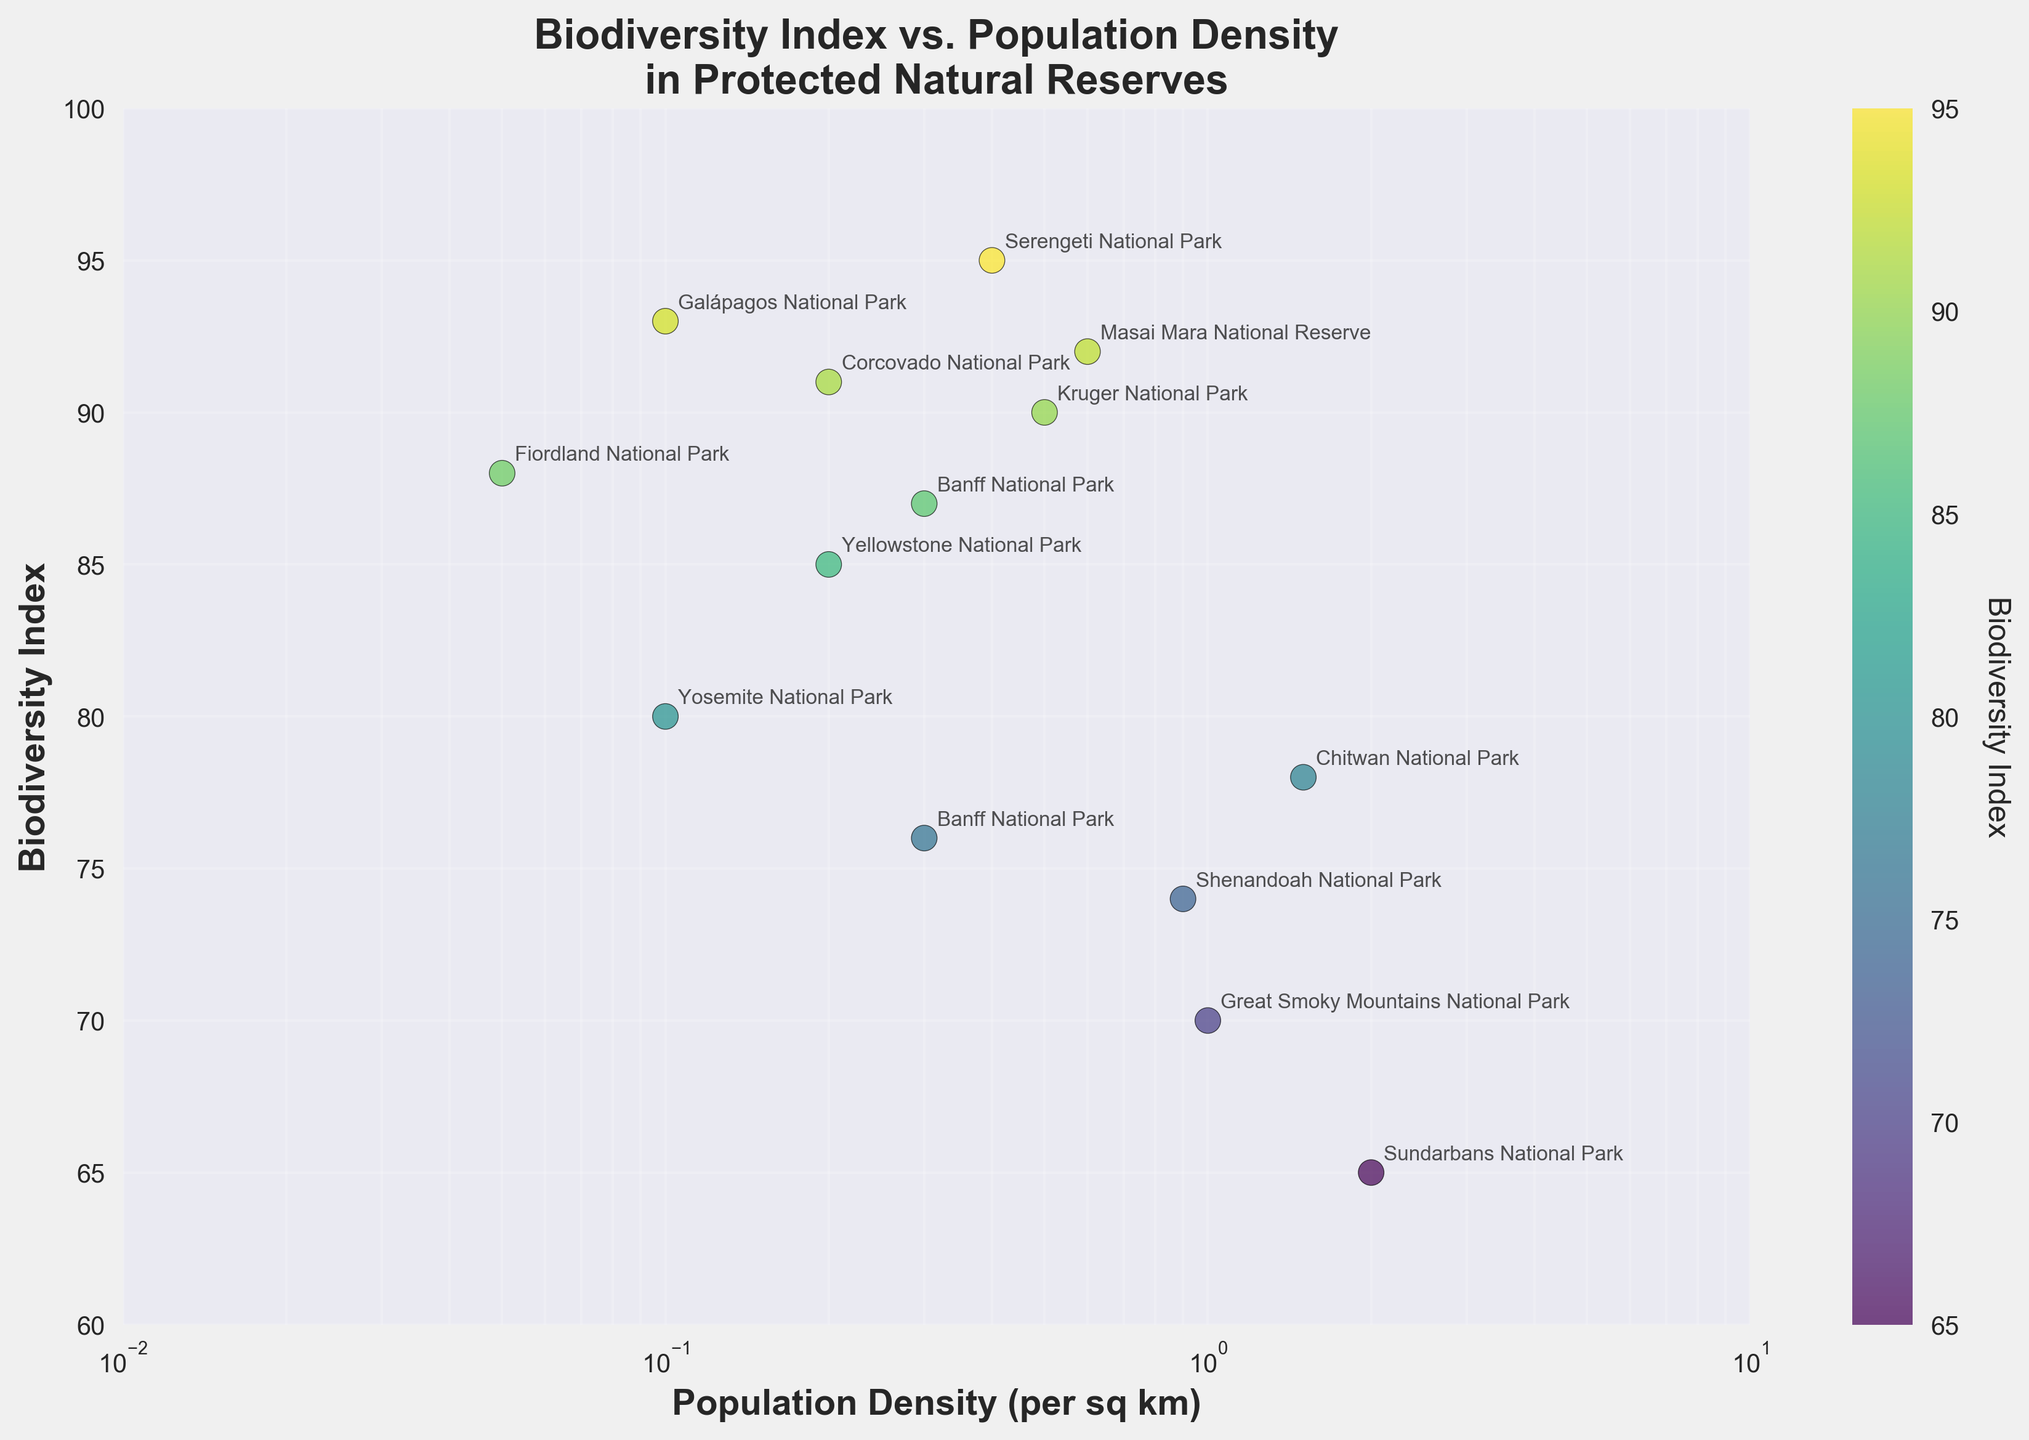What is the title of the scatter plot? The title is usually the text at the top of the figure describing the content. Here it states "Biodiversity Index vs. Population Density in Protected Natural Reserves".
Answer: Biodiversity Index vs. Population Density in Protected Natural Reserves Which natural reserve has the highest Biodiversity Index and what is its value? Look for the point with the maximum Biodiversity Index value on the y-axis. The highest point corresponds to Serengeti National Park with a Biodiversity Index of 95.
Answer: Serengeti National Park, 95 What is the range of the x-axis (Population Density)? Check the label of the x-axis and the scaling. The axis uses a logarithmic scale ranging from 0.01 to 10.
Answer: 0.01 to 10 How does Fiordland National Park's Population Density compare to Galápagos National Park's? Locate both points on the scatter plot and compare their positions on the logarithmic x-axis. Fiordland is at 0.05 while the Galápagos is at 0.1.
Answer: Fiordland < Galápagos Which reserve has a Population Density of 1.0 per sq km and what is its Biodiversity Index? Find the point at (1.0, y) on the plot. The corresponding Biodiversity Index for Great Smoky Mountains National Park is 70.
Answer: Great Smoky Mountains National Park, 70 Are there any reserves with the same Population Density and different Biodiversity Index? Look for points vertically aligned on the plot. Banff National Park appears twice with a Population Density of 0.3 but different Biodiversity Indices (76 and 87).
Answer: Yes, Banff National Park What is the average Biodiversity Index of the reserves with a Population Density of less than 0.5 per sq km? Identify reserves with Population Density < 0.5: Yellowstone (85), Kruger (90), Banff (87 and 76), Yosemite (80), Serengeti (95), Fiordland (88), Galápagos (93), and Corcovado (91). Sum of Biodiversity Indices is 785. Average = 785 / 9 = 87.22.
Answer: 87.22 Do any reserves have a Population Density greater than or equal to 1.5 per sq km and if so, what are their Biodiversity Indices? Find points with Population Density >= 1.5 on the plot. Sundarbans and Chitwan reserves fall in this category with Biodiversity Indices of 65 and 78, respectively.
Answer: Yes, 65 and 78 Which natural reserve with the Population Density of 0.2 has a higher Biodiversity Index, Yellowstone National Park or Corcovado National Park? Compare the y-values (Biodiversity Index) for points at Population Density of 0.2. Corcovado (91) is higher than Yellowstone (85).
Answer: Corcovado National Park Can you identify any outliers in terms of Biodiversity Index relative to Population Density? Sundarbans, with a relatively low Biodiversity Index (65) and high Population Density (2.0), stands out as an outlier on the plot.
Answer: Sundarbans National Park 